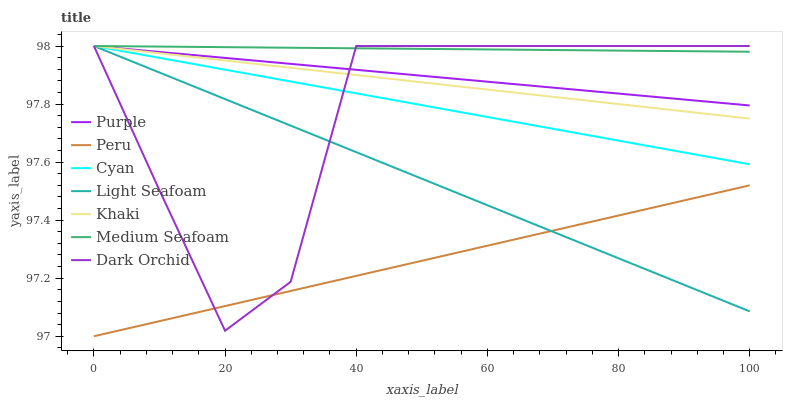Does Peru have the minimum area under the curve?
Answer yes or no. Yes. Does Medium Seafoam have the maximum area under the curve?
Answer yes or no. Yes. Does Purple have the minimum area under the curve?
Answer yes or no. No. Does Purple have the maximum area under the curve?
Answer yes or no. No. Is Medium Seafoam the smoothest?
Answer yes or no. Yes. Is Dark Orchid the roughest?
Answer yes or no. Yes. Is Purple the smoothest?
Answer yes or no. No. Is Purple the roughest?
Answer yes or no. No. Does Peru have the lowest value?
Answer yes or no. Yes. Does Purple have the lowest value?
Answer yes or no. No. Does Medium Seafoam have the highest value?
Answer yes or no. Yes. Does Peru have the highest value?
Answer yes or no. No. Is Peru less than Khaki?
Answer yes or no. Yes. Is Medium Seafoam greater than Peru?
Answer yes or no. Yes. Does Cyan intersect Dark Orchid?
Answer yes or no. Yes. Is Cyan less than Dark Orchid?
Answer yes or no. No. Is Cyan greater than Dark Orchid?
Answer yes or no. No. Does Peru intersect Khaki?
Answer yes or no. No. 